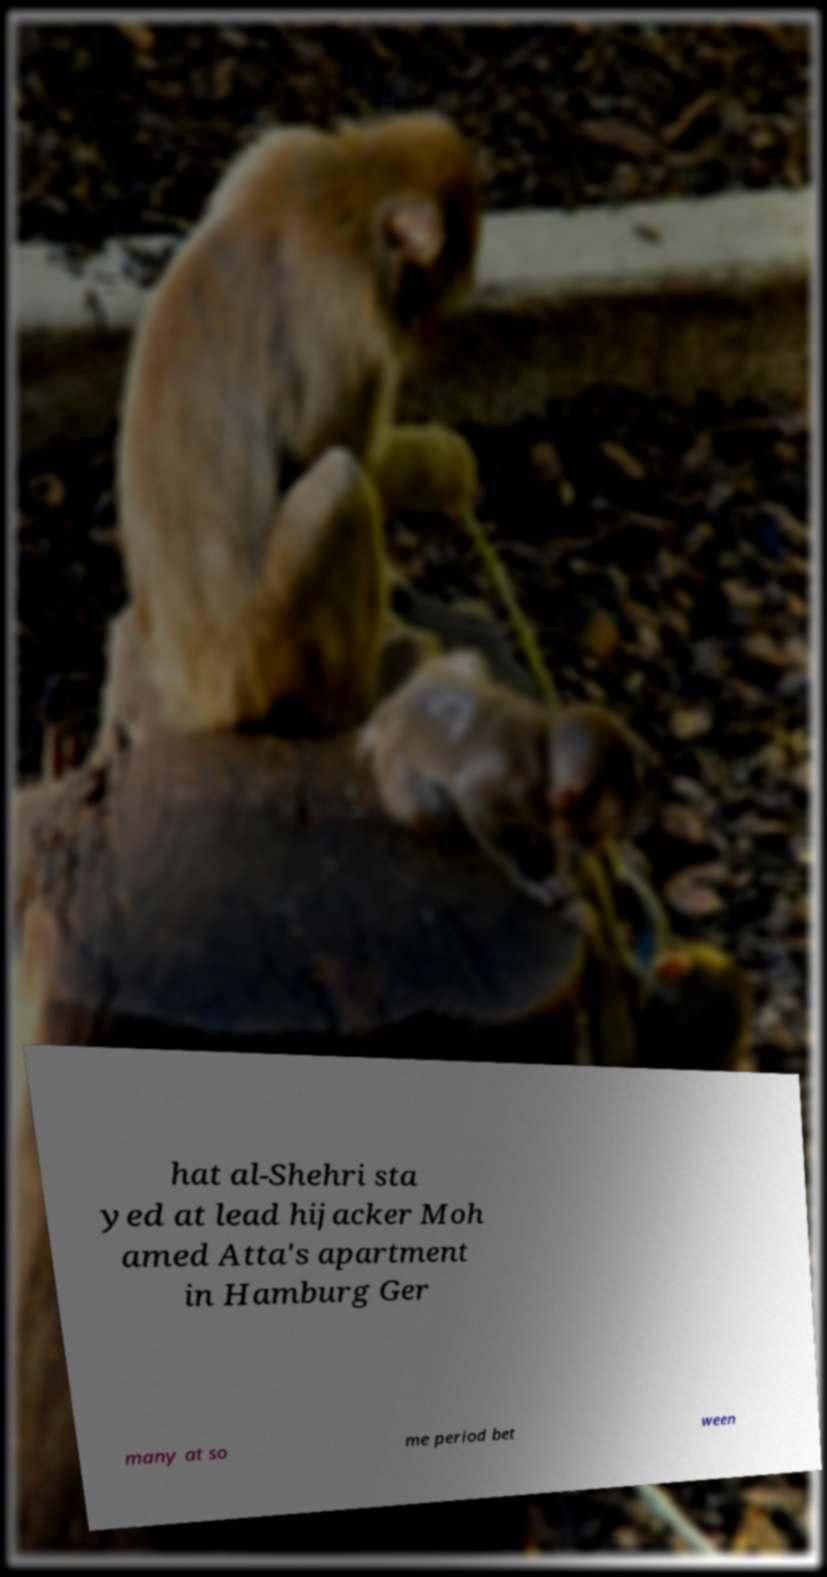Can you accurately transcribe the text from the provided image for me? hat al-Shehri sta yed at lead hijacker Moh amed Atta's apartment in Hamburg Ger many at so me period bet ween 